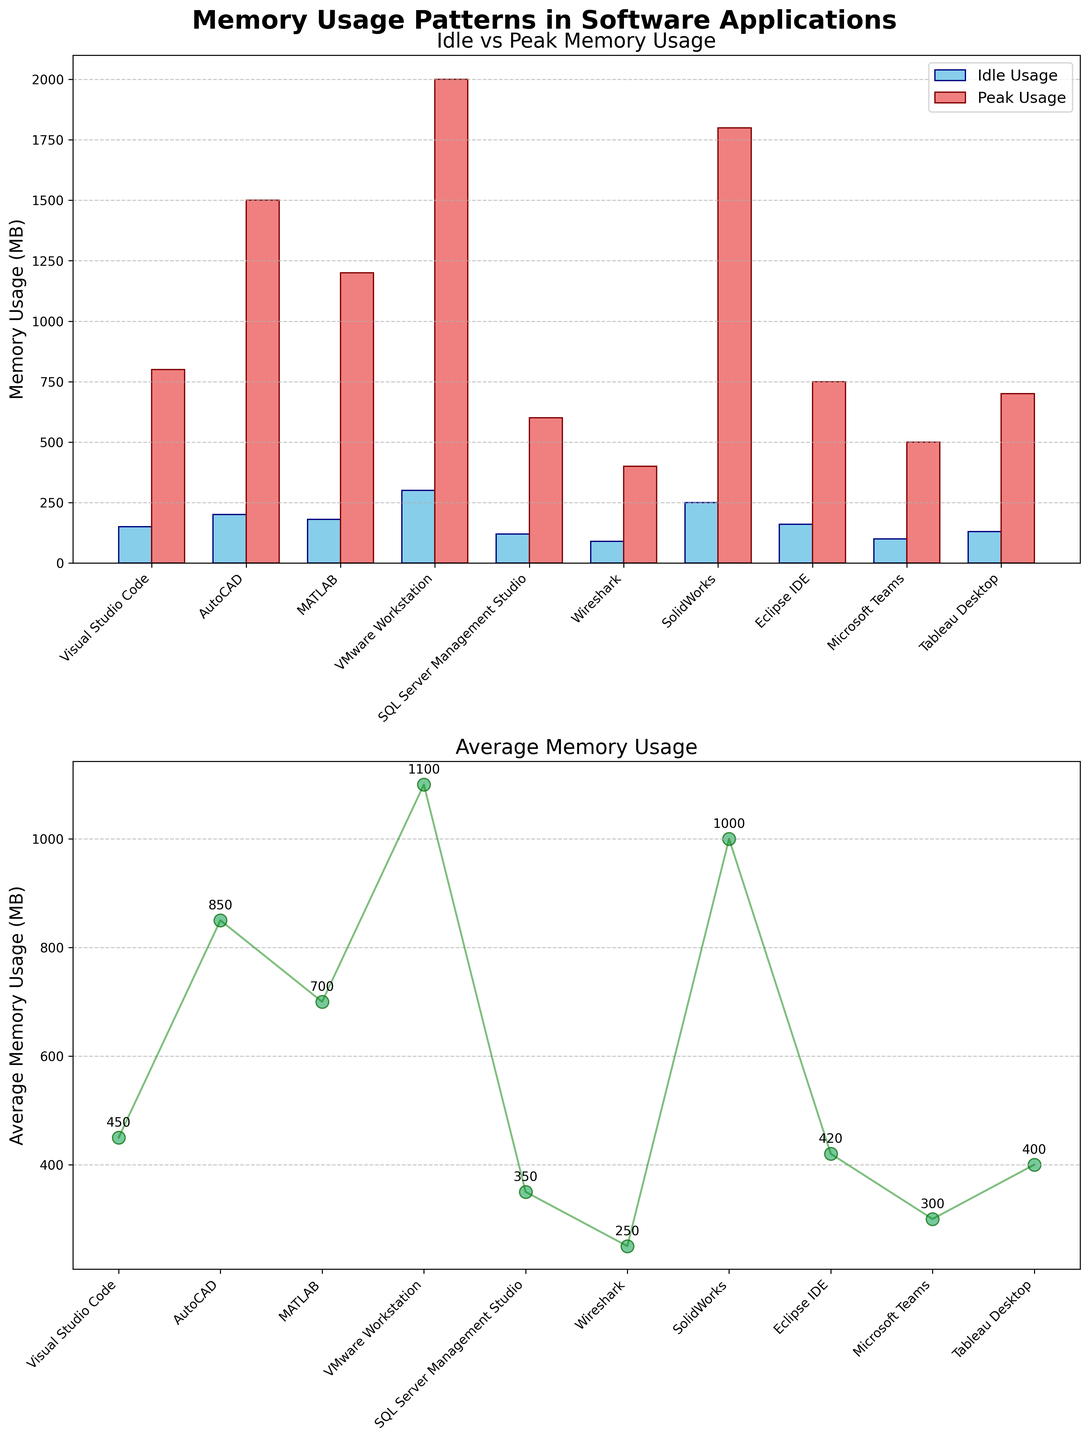Which application has the highest peak memory usage? The highest bar in the 'Peak Usage' part of the bar plot indicates the highest peak memory usage. VMware Workstation has the tallest bar at 2000 MB.
Answer: VMware Workstation What is the range of average memory usage for these applications? To find the range, identify the minimum and maximum average memory usage from the scatter plot. The minimum average usage is 250 MB (Wireshark), and the maximum is 1100 MB (VMware Workstation). The range is 1100 MB - 250 MB.
Answer: 850 MB How does MATLAB's peak memory usage compare to Visual Studio Code’s peak memory usage? Compare the heights of the 'Peak Usage' bars for MATLAB and Visual Studio Code. MATLAB’s peak memory usage is 1200 MB, which is higher than Visual Studio Code’s 800 MB.
Answer: MATLAB’s is higher Which application has the smallest idle memory usage, and what is its value? By examining the 'Idle Usage' bars, Wireshark has the shortest bar, indicating the smallest idle memory usage at 90 MB.
Answer: Wireshark, 90 MB What is the sum of average memory usage for Visual Studio Code and SQL Server Management Studio? From the scatter plot, the average memory usage for Visual Studio Code is 450 MB and for SQL Server Management Studio is 350 MB. The sum is 450 MB + 350 MB.
Answer: 800 MB Which two applications have similar average memory usage, and what are their approximate values? Look for points on the scatter plot that are close together. Visual Studio Code and Eclipse IDE have average usages approximately at 450 MB and 420 MB, respectively.
Answer: Visual Studio Code and Eclipse IDE, ~450 MB and ~420 MB Is there any application for which the peak memory usage is exactly twice the average memory usage? The applications and their values need to be checked to see if the peak memory usage is twice the average memory usage. No application meets this criteria exactly.
Answer: No What is the difference between the peak and idle memory usage of AutoCAD? From the 'Peak Usage' and 'Idle Usage' bars for AutoCAD, the peak usage is 1500 MB, and the idle usage is 200 MB. The difference is 1500 MB - 200 MB.
Answer: 1300 MB Which application has the second highest average memory usage? The scatter plot shows the average usages. SolidWorks, with 1000 MB, is the second highest after VMware Workstation.
Answer: SolidWorks 